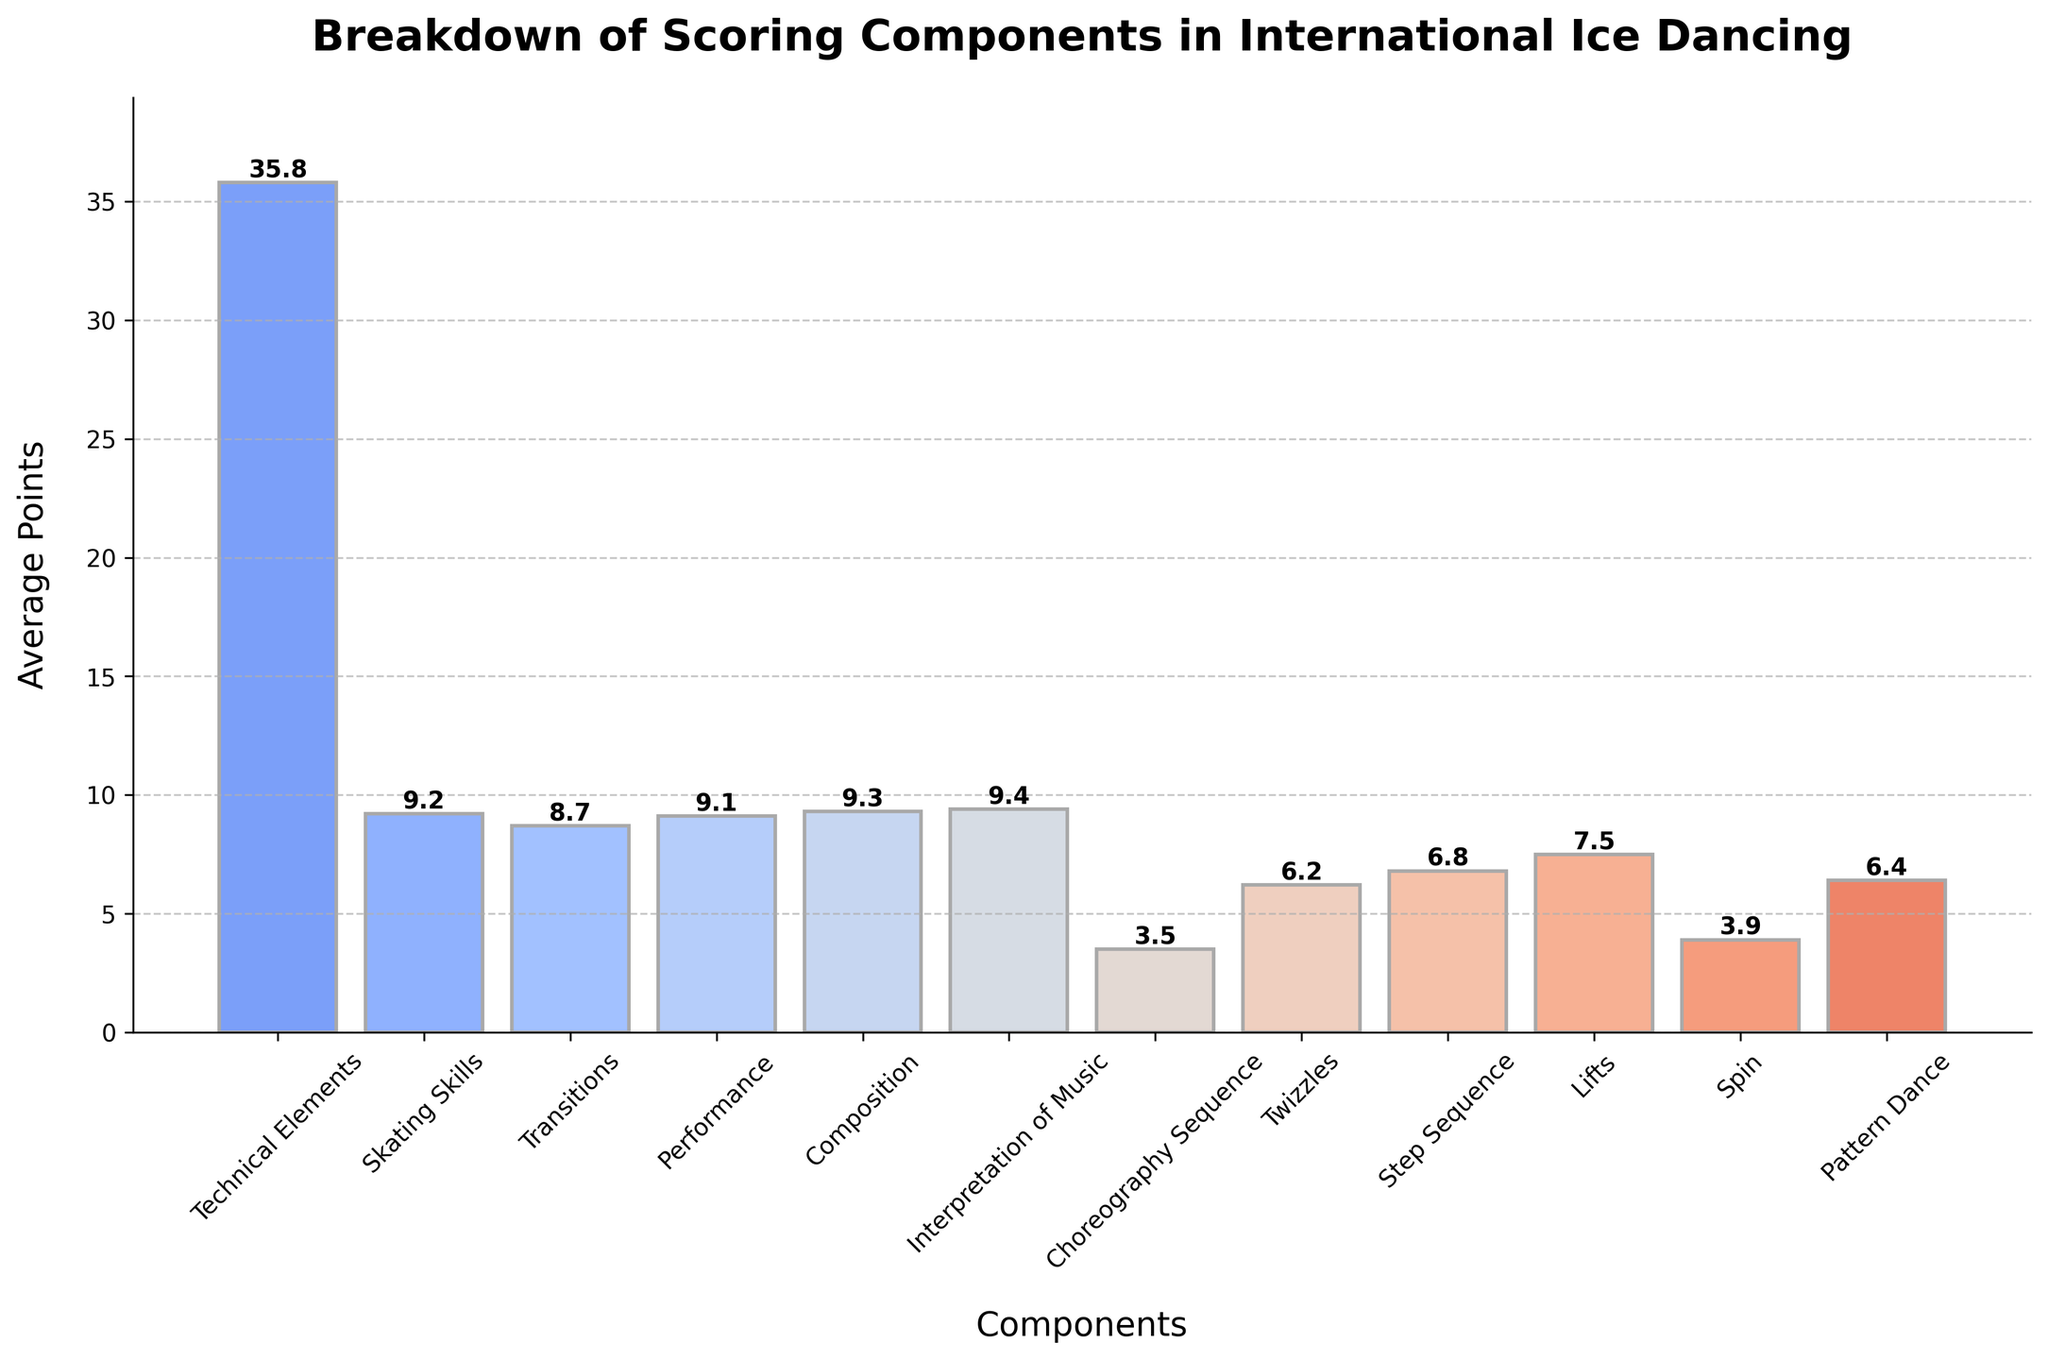What's the highest scoring component in international ice dancing competitions? By looking at the bar chart, you can easily see which bar is the tallest. In this case, the bar labeled "Interpretation of Music" has the highest value.
Answer: Interpretation of Music What's the difference in average points between "Interpretation of Music" and "Choreography Sequence"? Identify the average points for both components from the bars in the chart. Interpretation of Music has 9.4 points, and Choreography Sequence has 3.5 points. Subtract the value for Choreography Sequence from Interpretation of Music: 9.4 - 3.5
Answer: 5.9 Among "Technical Elements," "Skating Skills," and "Transitions," which component scores the lowest? Compare the heights of the bars labeled "Technical Elements," "Skating Skills," and "Transitions." The lowest bar represents the component with the lowest score. "Transitions" has a score of 8.7, which is lower than "Technical Elements" (35.8) and "Skating Skills" (9.2).
Answer: Transitions Do "Performance" and "Composition" have similar scores? Check the bars corresponding to "Performance" and "Composition." "Performance" has a score of 9.1, and "Composition" has a score of 9.3. The difference between their scores is small (9.3 - 9.1 = 0.2), indicating similar scores.
Answer: Yes What's the combined average score for "Step Sequence" and "Lifts"? Find the values for "Step Sequence" and "Lifts" in the chart and sum them: Step Sequence (6.8) + Lifts (7.5). Then, calculate the combined average: (6.8 + 7.5) = 14.3 / 2.
Answer: 7.15 Which component has a higher score: "Spin" or "Pattern Dance"? Look at the bars labeled "Spin" and "Pattern Dance." "Spin" has 3.9 points, while "Pattern Dance" has 6.4 points. "Pattern Dance" has the higher score.
Answer: Pattern Dance What is the total average score for all components shown in the chart? Add up all the average points from each component: 35.8 + 9.2 + 8.7 + 9.1 + 9.3 + 9.4 + 3.5 + 6.2 + 6.8 + 7.5 + 3.9 + 6.4. The sum is the total average score.
Answer: 115.8 Which color represents "Technical Elements" in the chart? Observe the color coding of the bars in the chart. The tallest bar corresponds to "Technical Elements." Look at the specific color used for this bar, which is the first color in the gradient from the coolwarm color scheme.
Answer: Blue (assumed based on coolwarm gradient's typical color range) Is the "Skating Skills" component above or below the middle range of the total average score? Compare "Skating Skills" (9.2) to the total average of all components divided by the number of components (115.8 / 12 = 9.65). "Skating Skills" (9.2) is below the middle range.
Answer: Below 